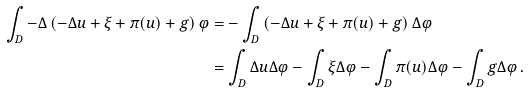<formula> <loc_0><loc_0><loc_500><loc_500>\int _ { D } - \Delta \left ( - \Delta u + \xi + \pi ( u ) + g \right ) \varphi & = - \int _ { D } \left ( - \Delta u + \xi + \pi ( u ) + g \right ) \Delta \varphi \\ & = \int _ { D } \Delta u \Delta \varphi - \int _ { D } \xi \Delta \varphi - \int _ { D } \pi ( u ) \Delta \varphi - \int _ { D } g \Delta \varphi \, .</formula> 